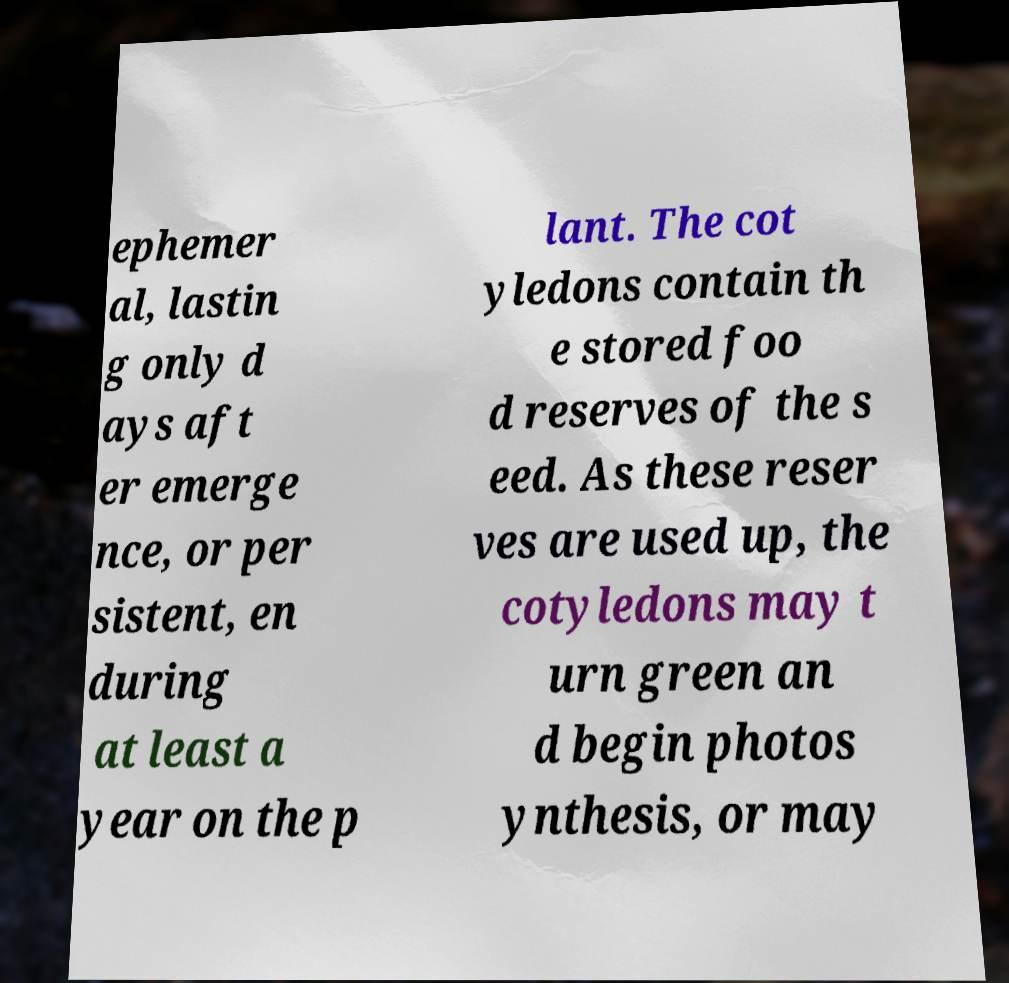Can you accurately transcribe the text from the provided image for me? ephemer al, lastin g only d ays aft er emerge nce, or per sistent, en during at least a year on the p lant. The cot yledons contain th e stored foo d reserves of the s eed. As these reser ves are used up, the cotyledons may t urn green an d begin photos ynthesis, or may 